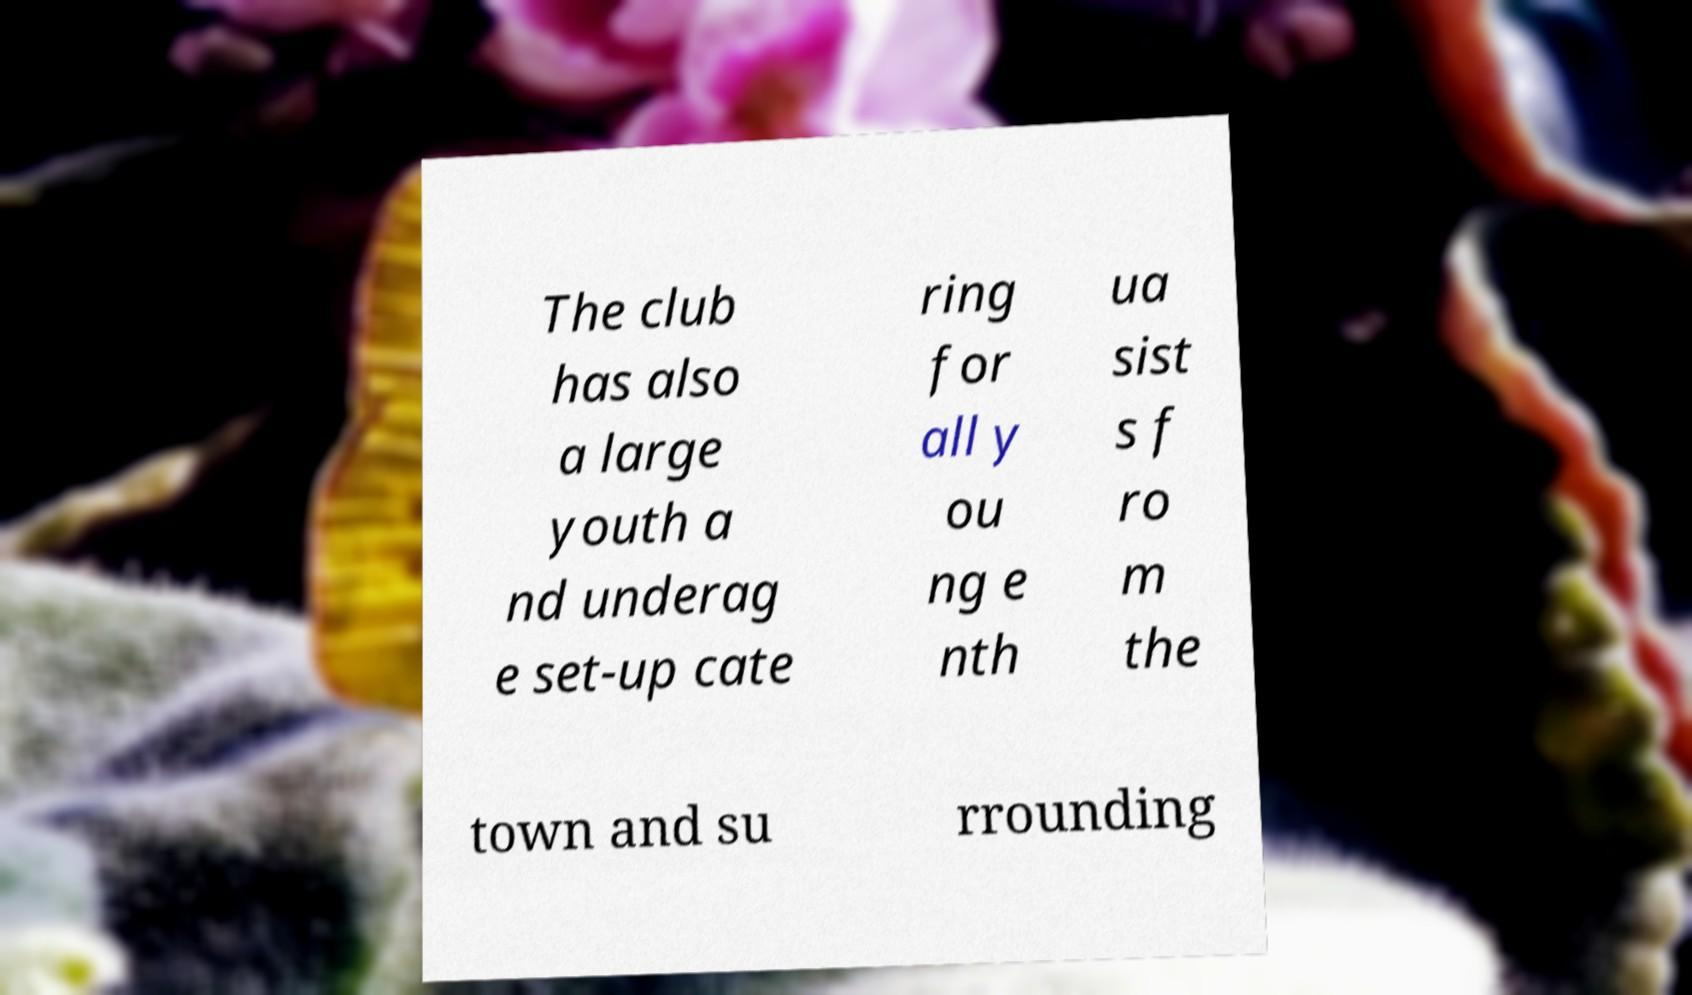Can you read and provide the text displayed in the image?This photo seems to have some interesting text. Can you extract and type it out for me? The club has also a large youth a nd underag e set-up cate ring for all y ou ng e nth ua sist s f ro m the town and su rrounding 